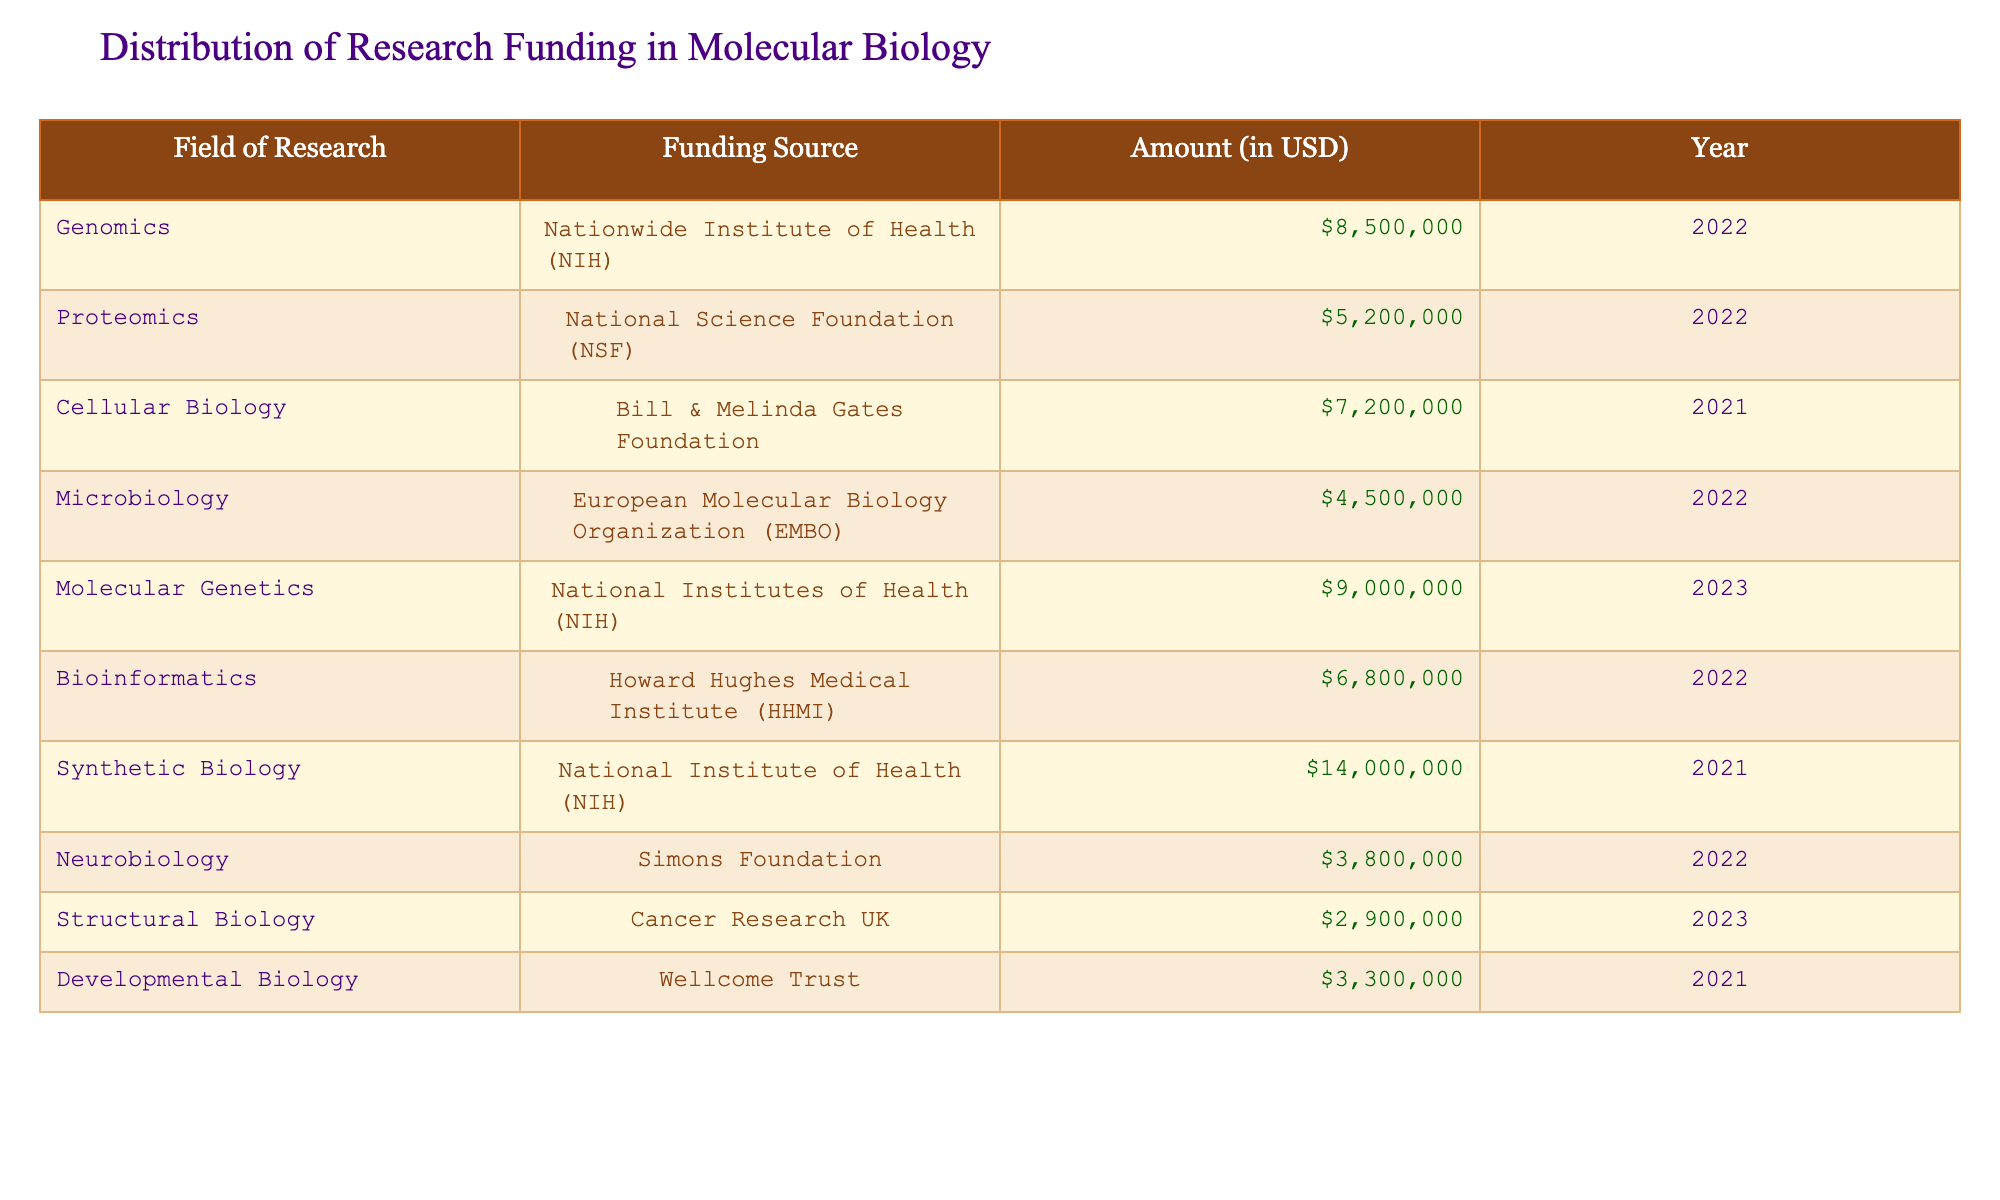What is the funding amount for Genomics from NIH in 2022? The table specifies that for the field of Genomics, the funding source is the Nationwide Institute of Health (NIH) and the amount is 8,500,000 USD for the year 2022.
Answer: 8,500,000 USD What is the total funding amount received from NIH? By examining the table, NIH is the funding source for Genomics (8,500,000), Molecular Genetics (9,000,000), and Synthetic Biology (14,000,000). Adding these amounts gives 8,500,000 + 9,000,000 + 14,000,000 = 31,500,000 USD.
Answer: 31,500,000 USD Which field of research received the highest funding, and what was the amount? Looking at the table, Synthetic Biology received the highest funding of 14,000,000 USD from NIH in 2021.
Answer: Synthetic Biology, 14,000,000 USD Was there any funding for Structural Biology in 2022? The table lists Structural Biology with a funding amount under Cancer Research UK, but it specifically states the year as 2023. Therefore, there was no funding for Structural Biology in 2022.
Answer: No What is the average funding amount across all research fields represented in the table? To find the average, first sum all the funding amounts: 8,500,000 + 5,200,000 + 7,200,000 + 4,500,000 + 9,000,000 + 6,800,000 + 14,000,000 + 3,800,000 + 2,900,000 + 3,300,000 = 60,200,000. There are 10 fields, so the average is 60,200,000 / 10 = 6,020,000 USD.
Answer: 6,020,000 USD Which funding source provided more than 6 million USD in 2022? The table lists two sources in 2022 with funding amounts exceeding 6 million USD: NIH (8,500,000) for Genomics and HHMI (6,800,000) for Bioinformatics.
Answer: NIH, HHMI What was the difference in funding between Developmental Biology and Microbiology? The funding for Developmental Biology is 3,300,000 USD and for Microbiology is 4,500,000 USD. The difference is 4,500,000 - 3,300,000 = 1,200,000 USD, meaning that Microbiology received more funding.
Answer: 1,200,000 USD Did the total funding for the year 2021 exceed that of 2022? Total funding for 2021 includes 7,200,000 (Cellular Biology) + 14,000,000 (Synthetic Biology) + 3,300,000 (Developmental Biology) = 24,500,000 USD. For 2022, it includes 8,500,000 (Genomics) + 5,200,000 (Proteomics) + 4,500,000 (Microbiology) + 6,800,000 (Bioinformatics) + 3,800,000 (Neurobiology) = 28,800,000 USD. Thus, 28,800,000 > 24,500,000.
Answer: Yes 